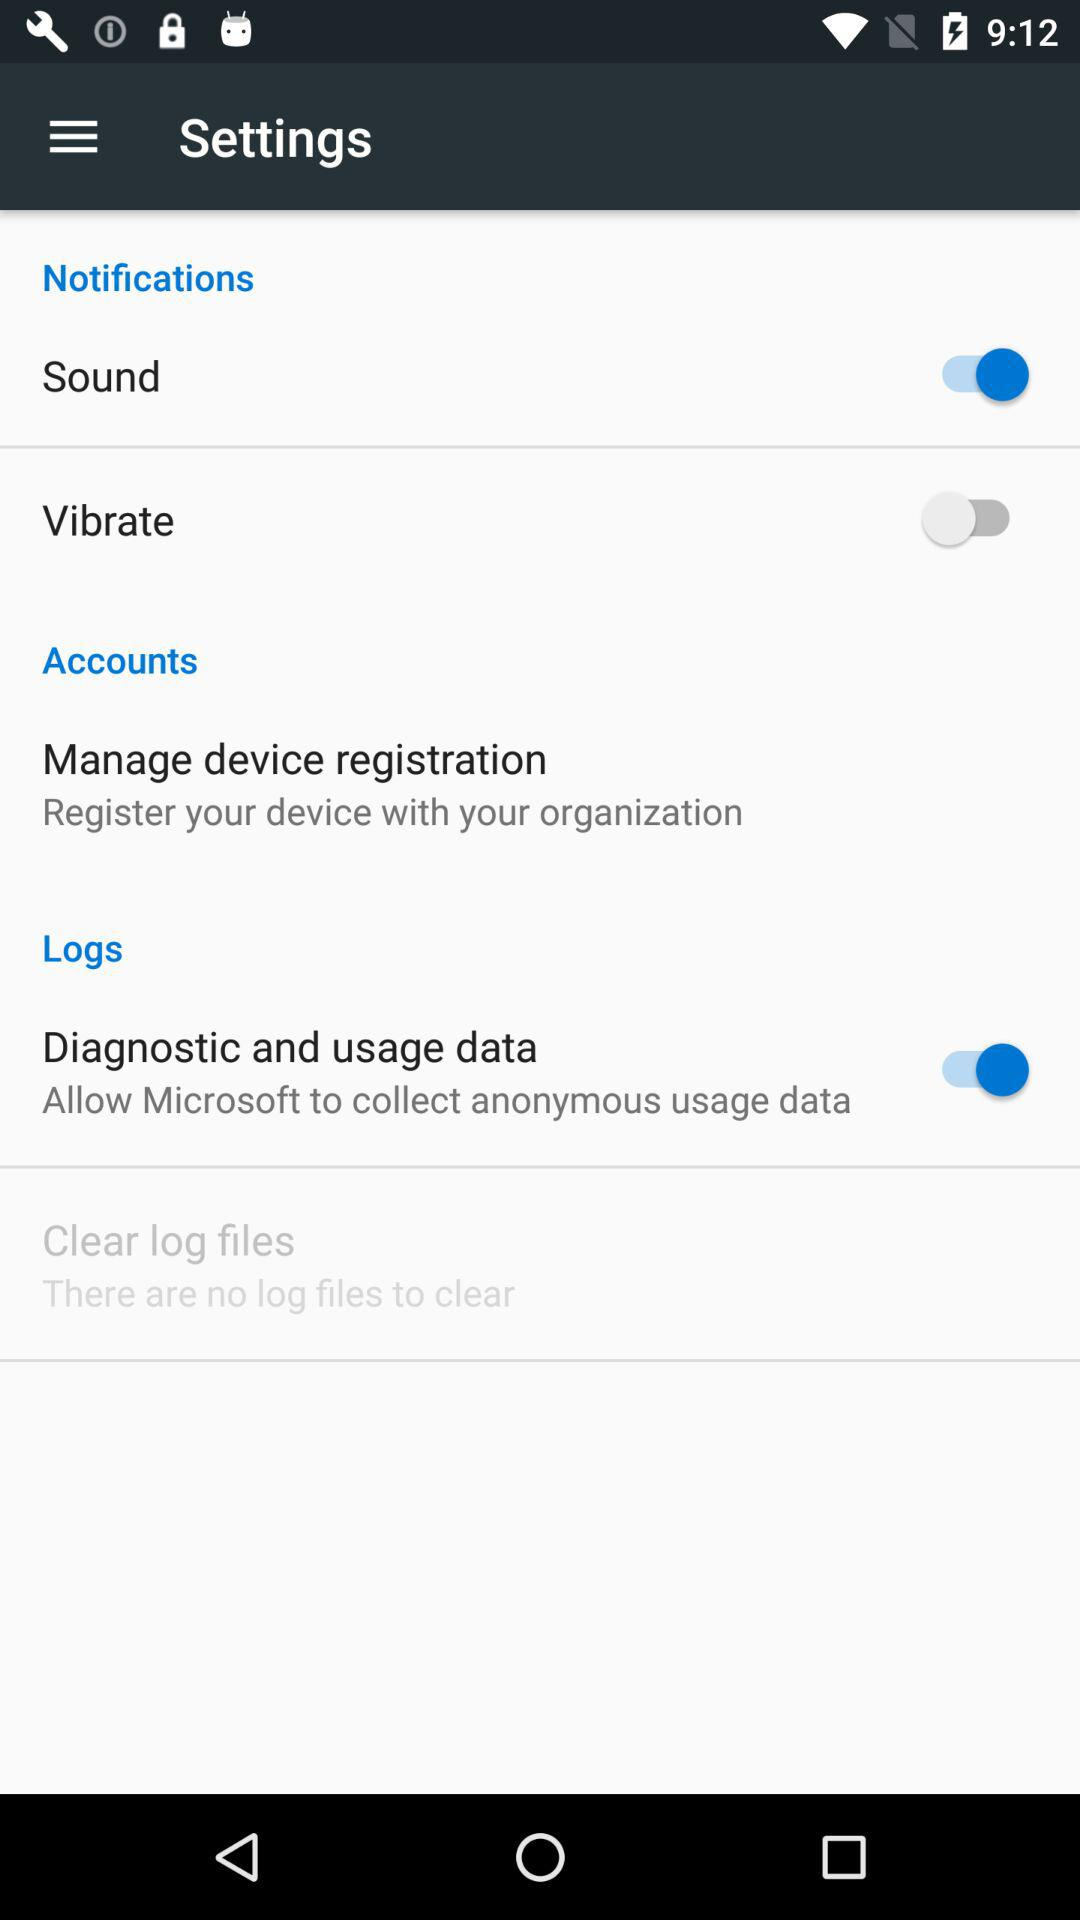What is the status of "Vibrate"? The status is "off". 